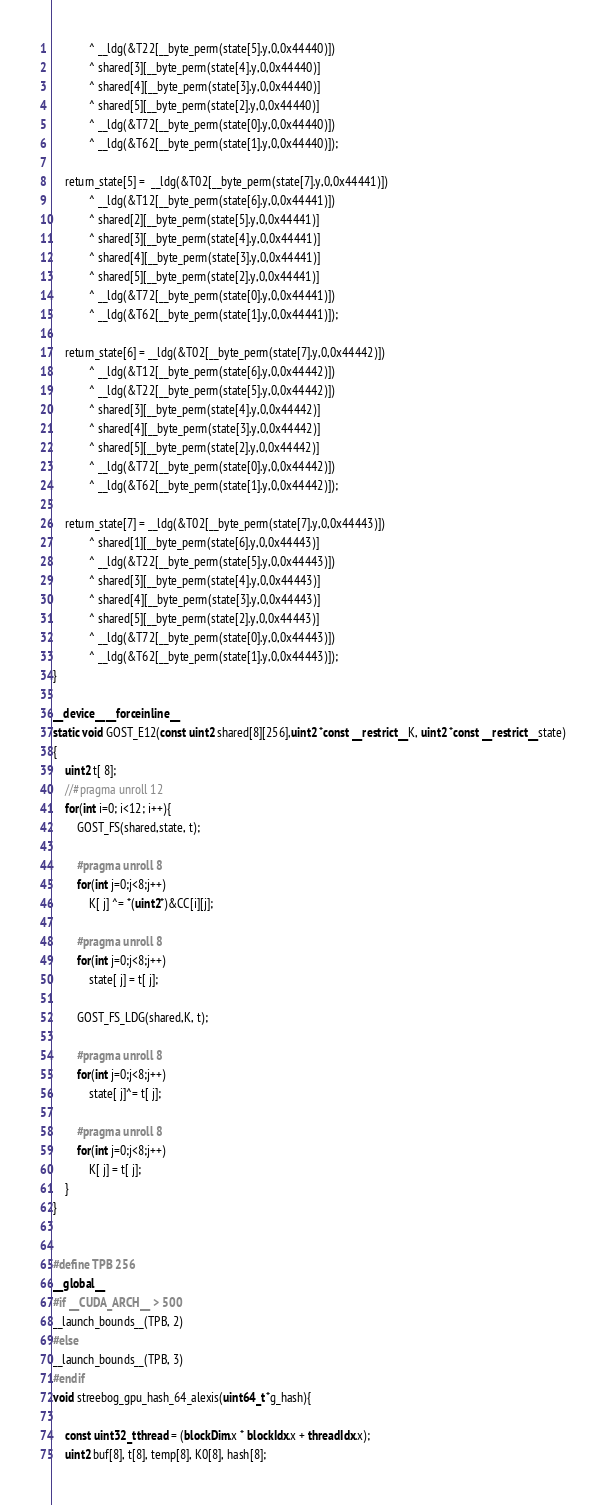Convert code to text. <code><loc_0><loc_0><loc_500><loc_500><_Cuda_>			^ __ldg(&T22[__byte_perm(state[5].y,0,0x44440)])
			^ shared[3][__byte_perm(state[4].y,0,0x44440)]
			^ shared[4][__byte_perm(state[3].y,0,0x44440)]
			^ shared[5][__byte_perm(state[2].y,0,0x44440)]
			^ __ldg(&T72[__byte_perm(state[0].y,0,0x44440)])
			^ __ldg(&T62[__byte_perm(state[1].y,0,0x44440)]);

	return_state[5] =  __ldg(&T02[__byte_perm(state[7].y,0,0x44441)])
			^ __ldg(&T12[__byte_perm(state[6].y,0,0x44441)])
			^ shared[2][__byte_perm(state[5].y,0,0x44441)]
			^ shared[3][__byte_perm(state[4].y,0,0x44441)]
			^ shared[4][__byte_perm(state[3].y,0,0x44441)]
			^ shared[5][__byte_perm(state[2].y,0,0x44441)]
			^ __ldg(&T72[__byte_perm(state[0].y,0,0x44441)])
			^ __ldg(&T62[__byte_perm(state[1].y,0,0x44441)]);

	return_state[6] = __ldg(&T02[__byte_perm(state[7].y,0,0x44442)])
			^ __ldg(&T12[__byte_perm(state[6].y,0,0x44442)])
			^ __ldg(&T22[__byte_perm(state[5].y,0,0x44442)])
			^ shared[3][__byte_perm(state[4].y,0,0x44442)]
			^ shared[4][__byte_perm(state[3].y,0,0x44442)]
			^ shared[5][__byte_perm(state[2].y,0,0x44442)]
			^ __ldg(&T72[__byte_perm(state[0].y,0,0x44442)])
			^ __ldg(&T62[__byte_perm(state[1].y,0,0x44442)]);

	return_state[7] = __ldg(&T02[__byte_perm(state[7].y,0,0x44443)])
			^ shared[1][__byte_perm(state[6].y,0,0x44443)]
			^ __ldg(&T22[__byte_perm(state[5].y,0,0x44443)])
			^ shared[3][__byte_perm(state[4].y,0,0x44443)]
			^ shared[4][__byte_perm(state[3].y,0,0x44443)]
			^ shared[5][__byte_perm(state[2].y,0,0x44443)]
			^ __ldg(&T72[__byte_perm(state[0].y,0,0x44443)])
			^ __ldg(&T62[__byte_perm(state[1].y,0,0x44443)]);
}

__device__ __forceinline__
static void GOST_E12(const uint2 shared[8][256],uint2 *const __restrict__ K, uint2 *const __restrict__ state)
{
	uint2 t[ 8];
	//#pragma unroll 12
	for(int i=0; i<12; i++){
		GOST_FS(shared,state, t);

		#pragma unroll 8
		for(int j=0;j<8;j++)
			K[ j] ^= *(uint2*)&CC[i][j];

		#pragma unroll 8
		for(int j=0;j<8;j++)
			state[ j] = t[ j];

		GOST_FS_LDG(shared,K, t);

		#pragma unroll 8
		for(int j=0;j<8;j++)
			state[ j]^= t[ j];

		#pragma unroll 8
		for(int j=0;j<8;j++)
			K[ j] = t[ j];
	}
}


#define TPB 256
__global__
#if __CUDA_ARCH__ > 500
__launch_bounds__(TPB, 2)
#else
__launch_bounds__(TPB, 3)
#endif
void streebog_gpu_hash_64_alexis(uint64_t *g_hash){

	const uint32_t thread = (blockDim.x * blockIdx.x + threadIdx.x);
	uint2 buf[8], t[8], temp[8], K0[8], hash[8];
</code> 